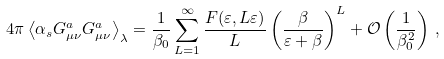Convert formula to latex. <formula><loc_0><loc_0><loc_500><loc_500>4 \pi \left < \alpha _ { s } G ^ { a } _ { \mu \nu } G ^ { a } _ { \mu \nu } \right > _ { \lambda } = \frac { 1 } { \beta _ { 0 } } \sum _ { L = 1 } ^ { \infty } \frac { F ( \varepsilon , L \varepsilon ) } { L } \left ( \frac { \beta } { \varepsilon + \beta } \right ) ^ { L } + \mathcal { O } \left ( \frac { 1 } { \beta _ { 0 } ^ { 2 } } \right ) \, ,</formula> 